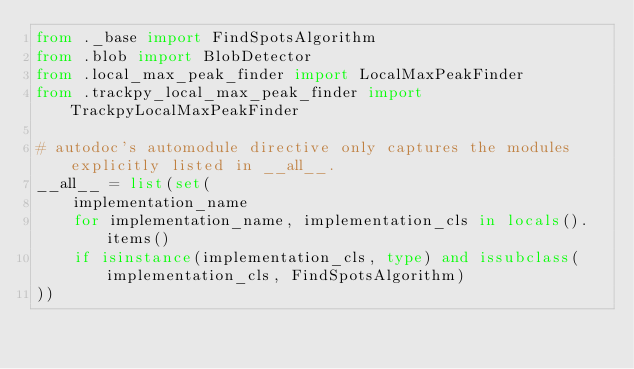Convert code to text. <code><loc_0><loc_0><loc_500><loc_500><_Python_>from ._base import FindSpotsAlgorithm
from .blob import BlobDetector
from .local_max_peak_finder import LocalMaxPeakFinder
from .trackpy_local_max_peak_finder import TrackpyLocalMaxPeakFinder

# autodoc's automodule directive only captures the modules explicitly listed in __all__.
__all__ = list(set(
    implementation_name
    for implementation_name, implementation_cls in locals().items()
    if isinstance(implementation_cls, type) and issubclass(implementation_cls, FindSpotsAlgorithm)
))
</code> 